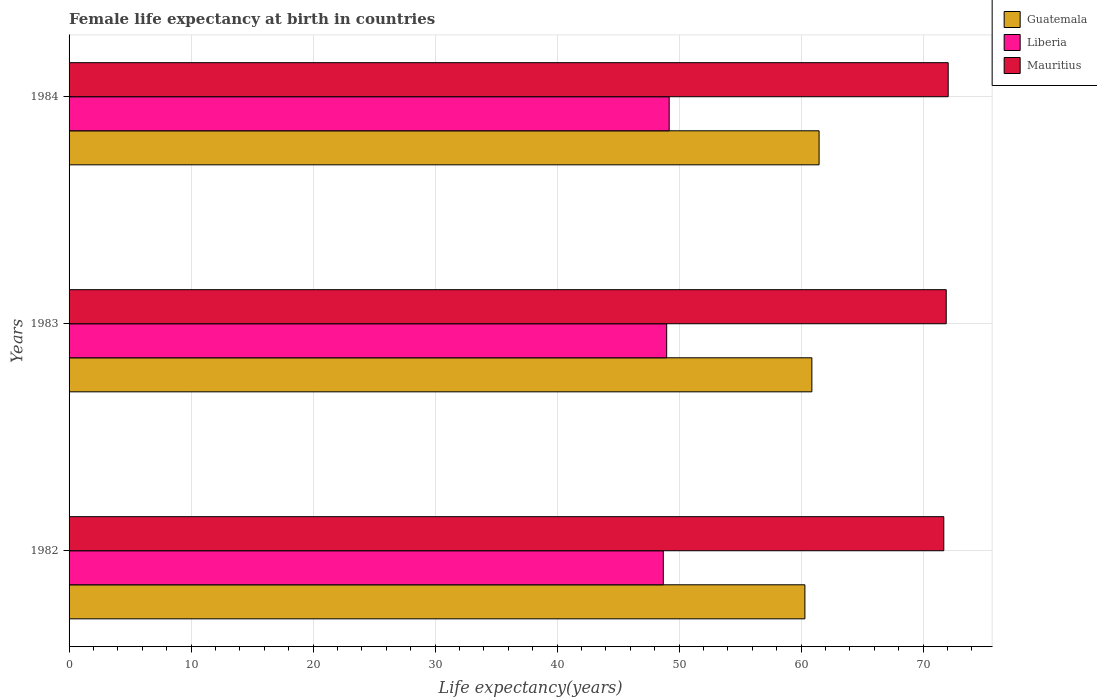How many different coloured bars are there?
Provide a succinct answer. 3. How many groups of bars are there?
Offer a terse response. 3. Are the number of bars per tick equal to the number of legend labels?
Your answer should be very brief. Yes. What is the female life expectancy at birth in Guatemala in 1982?
Provide a succinct answer. 60.31. Across all years, what is the maximum female life expectancy at birth in Mauritius?
Make the answer very short. 72.06. Across all years, what is the minimum female life expectancy at birth in Guatemala?
Keep it short and to the point. 60.31. In which year was the female life expectancy at birth in Guatemala maximum?
Offer a very short reply. 1984. In which year was the female life expectancy at birth in Liberia minimum?
Offer a terse response. 1982. What is the total female life expectancy at birth in Guatemala in the graph?
Ensure brevity in your answer.  182.67. What is the difference between the female life expectancy at birth in Mauritius in 1982 and that in 1983?
Your response must be concise. -0.2. What is the difference between the female life expectancy at birth in Guatemala in 1982 and the female life expectancy at birth in Mauritius in 1984?
Give a very brief answer. -11.74. What is the average female life expectancy at birth in Guatemala per year?
Your answer should be compact. 60.89. In the year 1984, what is the difference between the female life expectancy at birth in Mauritius and female life expectancy at birth in Guatemala?
Your answer should be compact. 10.58. In how many years, is the female life expectancy at birth in Guatemala greater than 10 years?
Your answer should be very brief. 3. What is the ratio of the female life expectancy at birth in Mauritius in 1982 to that in 1984?
Your answer should be compact. 1. Is the female life expectancy at birth in Liberia in 1982 less than that in 1984?
Provide a succinct answer. Yes. What is the difference between the highest and the second highest female life expectancy at birth in Liberia?
Give a very brief answer. 0.2. What is the difference between the highest and the lowest female life expectancy at birth in Liberia?
Provide a short and direct response. 0.48. What does the 1st bar from the top in 1984 represents?
Your response must be concise. Mauritius. What does the 2nd bar from the bottom in 1982 represents?
Give a very brief answer. Liberia. Is it the case that in every year, the sum of the female life expectancy at birth in Guatemala and female life expectancy at birth in Mauritius is greater than the female life expectancy at birth in Liberia?
Your answer should be compact. Yes. How many years are there in the graph?
Your response must be concise. 3. What is the difference between two consecutive major ticks on the X-axis?
Offer a terse response. 10. Does the graph contain grids?
Provide a short and direct response. Yes. What is the title of the graph?
Keep it short and to the point. Female life expectancy at birth in countries. Does "Australia" appear as one of the legend labels in the graph?
Keep it short and to the point. No. What is the label or title of the X-axis?
Give a very brief answer. Life expectancy(years). What is the label or title of the Y-axis?
Your response must be concise. Years. What is the Life expectancy(years) of Guatemala in 1982?
Your answer should be very brief. 60.31. What is the Life expectancy(years) of Liberia in 1982?
Make the answer very short. 48.71. What is the Life expectancy(years) in Mauritius in 1982?
Offer a very short reply. 71.7. What is the Life expectancy(years) of Guatemala in 1983?
Your answer should be very brief. 60.88. What is the Life expectancy(years) of Liberia in 1983?
Offer a terse response. 48.98. What is the Life expectancy(years) in Mauritius in 1983?
Provide a succinct answer. 71.9. What is the Life expectancy(years) in Guatemala in 1984?
Provide a short and direct response. 61.48. What is the Life expectancy(years) in Liberia in 1984?
Offer a very short reply. 49.19. What is the Life expectancy(years) of Mauritius in 1984?
Offer a terse response. 72.06. Across all years, what is the maximum Life expectancy(years) in Guatemala?
Make the answer very short. 61.48. Across all years, what is the maximum Life expectancy(years) of Liberia?
Provide a short and direct response. 49.19. Across all years, what is the maximum Life expectancy(years) of Mauritius?
Make the answer very short. 72.06. Across all years, what is the minimum Life expectancy(years) in Guatemala?
Make the answer very short. 60.31. Across all years, what is the minimum Life expectancy(years) of Liberia?
Your answer should be compact. 48.71. Across all years, what is the minimum Life expectancy(years) in Mauritius?
Give a very brief answer. 71.7. What is the total Life expectancy(years) in Guatemala in the graph?
Provide a short and direct response. 182.67. What is the total Life expectancy(years) of Liberia in the graph?
Your answer should be compact. 146.88. What is the total Life expectancy(years) of Mauritius in the graph?
Give a very brief answer. 215.65. What is the difference between the Life expectancy(years) of Guatemala in 1982 and that in 1983?
Keep it short and to the point. -0.57. What is the difference between the Life expectancy(years) in Liberia in 1982 and that in 1983?
Keep it short and to the point. -0.28. What is the difference between the Life expectancy(years) of Mauritius in 1982 and that in 1983?
Offer a very short reply. -0.2. What is the difference between the Life expectancy(years) of Guatemala in 1982 and that in 1984?
Offer a very short reply. -1.16. What is the difference between the Life expectancy(years) in Liberia in 1982 and that in 1984?
Your response must be concise. -0.48. What is the difference between the Life expectancy(years) in Mauritius in 1982 and that in 1984?
Your answer should be very brief. -0.36. What is the difference between the Life expectancy(years) in Guatemala in 1983 and that in 1984?
Make the answer very short. -0.59. What is the difference between the Life expectancy(years) of Liberia in 1983 and that in 1984?
Make the answer very short. -0.2. What is the difference between the Life expectancy(years) of Mauritius in 1983 and that in 1984?
Keep it short and to the point. -0.16. What is the difference between the Life expectancy(years) in Guatemala in 1982 and the Life expectancy(years) in Liberia in 1983?
Your response must be concise. 11.33. What is the difference between the Life expectancy(years) of Guatemala in 1982 and the Life expectancy(years) of Mauritius in 1983?
Give a very brief answer. -11.58. What is the difference between the Life expectancy(years) of Liberia in 1982 and the Life expectancy(years) of Mauritius in 1983?
Your response must be concise. -23.19. What is the difference between the Life expectancy(years) of Guatemala in 1982 and the Life expectancy(years) of Liberia in 1984?
Offer a terse response. 11.12. What is the difference between the Life expectancy(years) of Guatemala in 1982 and the Life expectancy(years) of Mauritius in 1984?
Make the answer very short. -11.74. What is the difference between the Life expectancy(years) in Liberia in 1982 and the Life expectancy(years) in Mauritius in 1984?
Give a very brief answer. -23.35. What is the difference between the Life expectancy(years) of Guatemala in 1983 and the Life expectancy(years) of Liberia in 1984?
Offer a very short reply. 11.7. What is the difference between the Life expectancy(years) in Guatemala in 1983 and the Life expectancy(years) in Mauritius in 1984?
Ensure brevity in your answer.  -11.17. What is the difference between the Life expectancy(years) of Liberia in 1983 and the Life expectancy(years) of Mauritius in 1984?
Keep it short and to the point. -23.07. What is the average Life expectancy(years) in Guatemala per year?
Ensure brevity in your answer.  60.89. What is the average Life expectancy(years) in Liberia per year?
Your answer should be compact. 48.96. What is the average Life expectancy(years) of Mauritius per year?
Give a very brief answer. 71.88. In the year 1982, what is the difference between the Life expectancy(years) of Guatemala and Life expectancy(years) of Liberia?
Make the answer very short. 11.61. In the year 1982, what is the difference between the Life expectancy(years) in Guatemala and Life expectancy(years) in Mauritius?
Provide a short and direct response. -11.38. In the year 1982, what is the difference between the Life expectancy(years) in Liberia and Life expectancy(years) in Mauritius?
Ensure brevity in your answer.  -22.99. In the year 1983, what is the difference between the Life expectancy(years) of Guatemala and Life expectancy(years) of Liberia?
Keep it short and to the point. 11.9. In the year 1983, what is the difference between the Life expectancy(years) in Guatemala and Life expectancy(years) in Mauritius?
Give a very brief answer. -11.01. In the year 1983, what is the difference between the Life expectancy(years) of Liberia and Life expectancy(years) of Mauritius?
Provide a succinct answer. -22.91. In the year 1984, what is the difference between the Life expectancy(years) in Guatemala and Life expectancy(years) in Liberia?
Your answer should be compact. 12.29. In the year 1984, what is the difference between the Life expectancy(years) of Guatemala and Life expectancy(years) of Mauritius?
Give a very brief answer. -10.58. In the year 1984, what is the difference between the Life expectancy(years) in Liberia and Life expectancy(years) in Mauritius?
Your answer should be compact. -22.87. What is the ratio of the Life expectancy(years) in Guatemala in 1982 to that in 1983?
Make the answer very short. 0.99. What is the ratio of the Life expectancy(years) in Liberia in 1982 to that in 1983?
Give a very brief answer. 0.99. What is the ratio of the Life expectancy(years) of Guatemala in 1982 to that in 1984?
Ensure brevity in your answer.  0.98. What is the ratio of the Life expectancy(years) of Liberia in 1982 to that in 1984?
Provide a succinct answer. 0.99. What is the ratio of the Life expectancy(years) of Liberia in 1983 to that in 1984?
Ensure brevity in your answer.  1. What is the difference between the highest and the second highest Life expectancy(years) in Guatemala?
Provide a succinct answer. 0.59. What is the difference between the highest and the second highest Life expectancy(years) in Liberia?
Offer a very short reply. 0.2. What is the difference between the highest and the second highest Life expectancy(years) of Mauritius?
Ensure brevity in your answer.  0.16. What is the difference between the highest and the lowest Life expectancy(years) of Guatemala?
Offer a very short reply. 1.16. What is the difference between the highest and the lowest Life expectancy(years) in Liberia?
Offer a very short reply. 0.48. What is the difference between the highest and the lowest Life expectancy(years) of Mauritius?
Give a very brief answer. 0.36. 